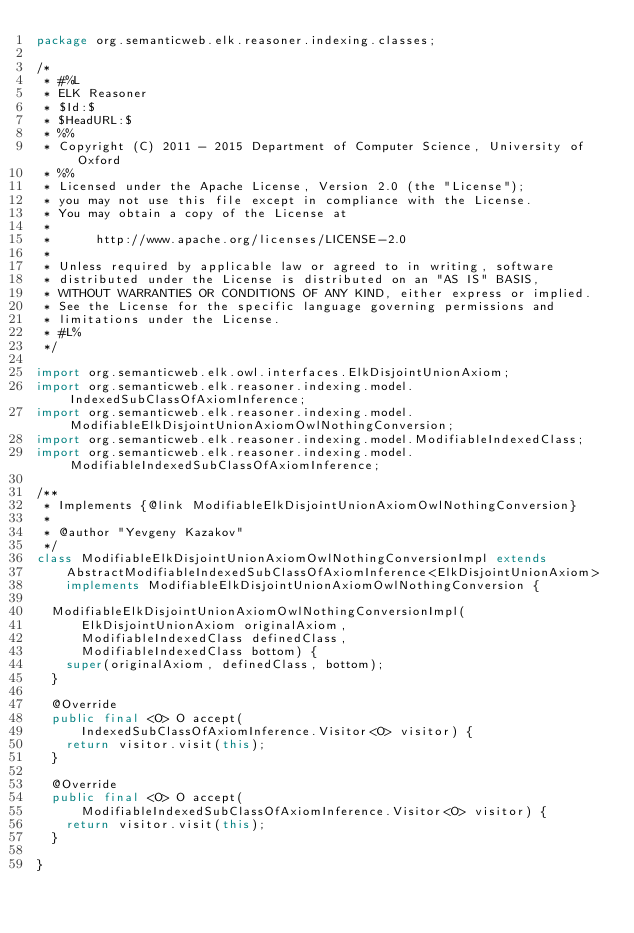<code> <loc_0><loc_0><loc_500><loc_500><_Java_>package org.semanticweb.elk.reasoner.indexing.classes;

/*
 * #%L
 * ELK Reasoner
 * $Id:$
 * $HeadURL:$
 * %%
 * Copyright (C) 2011 - 2015 Department of Computer Science, University of Oxford
 * %%
 * Licensed under the Apache License, Version 2.0 (the "License");
 * you may not use this file except in compliance with the License.
 * You may obtain a copy of the License at
 * 
 *      http://www.apache.org/licenses/LICENSE-2.0
 * 
 * Unless required by applicable law or agreed to in writing, software
 * distributed under the License is distributed on an "AS IS" BASIS,
 * WITHOUT WARRANTIES OR CONDITIONS OF ANY KIND, either express or implied.
 * See the License for the specific language governing permissions and
 * limitations under the License.
 * #L%
 */

import org.semanticweb.elk.owl.interfaces.ElkDisjointUnionAxiom;
import org.semanticweb.elk.reasoner.indexing.model.IndexedSubClassOfAxiomInference;
import org.semanticweb.elk.reasoner.indexing.model.ModifiableElkDisjointUnionAxiomOwlNothingConversion;
import org.semanticweb.elk.reasoner.indexing.model.ModifiableIndexedClass;
import org.semanticweb.elk.reasoner.indexing.model.ModifiableIndexedSubClassOfAxiomInference;

/**
 * Implements {@link ModifiableElkDisjointUnionAxiomOwlNothingConversion}
 * 
 * @author "Yevgeny Kazakov"
 */
class ModifiableElkDisjointUnionAxiomOwlNothingConversionImpl extends
		AbstractModifiableIndexedSubClassOfAxiomInference<ElkDisjointUnionAxiom>
		implements ModifiableElkDisjointUnionAxiomOwlNothingConversion {

	ModifiableElkDisjointUnionAxiomOwlNothingConversionImpl(
			ElkDisjointUnionAxiom originalAxiom,
			ModifiableIndexedClass definedClass,
			ModifiableIndexedClass bottom) {
		super(originalAxiom, definedClass, bottom);
	}

	@Override
	public final <O> O accept(
			IndexedSubClassOfAxiomInference.Visitor<O> visitor) {
		return visitor.visit(this);
	}

	@Override
	public final <O> O accept(
			ModifiableIndexedSubClassOfAxiomInference.Visitor<O> visitor) {
		return visitor.visit(this);
	}

}
</code> 